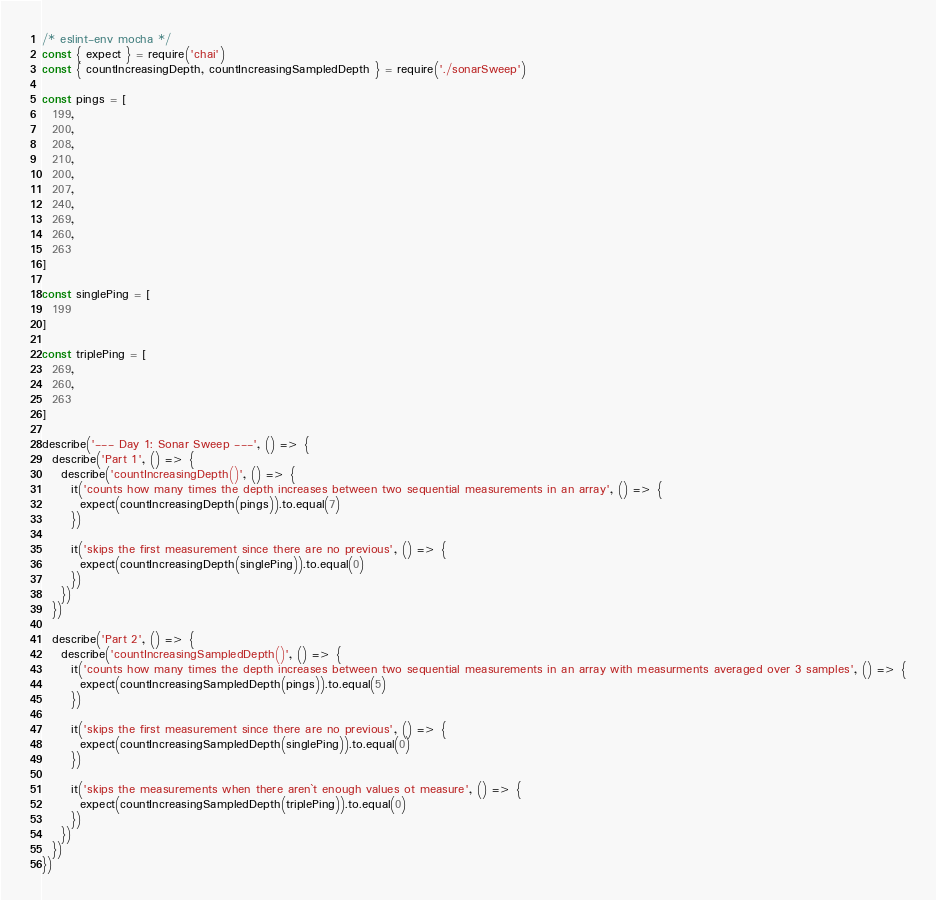<code> <loc_0><loc_0><loc_500><loc_500><_JavaScript_>/* eslint-env mocha */
const { expect } = require('chai')
const { countIncreasingDepth, countIncreasingSampledDepth } = require('./sonarSweep')

const pings = [
  199,
  200,
  208,
  210,
  200,
  207,
  240,
  269,
  260,
  263
]

const singlePing = [
  199
]

const triplePing = [
  269,
  260,
  263
]

describe('--- Day 1: Sonar Sweep ---', () => {
  describe('Part 1', () => {
    describe('countIncreasingDepth()', () => {
      it('counts how many times the depth increases between two sequential measurements in an array', () => {
        expect(countIncreasingDepth(pings)).to.equal(7)
      })

      it('skips the first measurement since there are no previous', () => {
        expect(countIncreasingDepth(singlePing)).to.equal(0)
      })
    })
  })

  describe('Part 2', () => {
    describe('countIncreasingSampledDepth()', () => {
      it('counts how many times the depth increases between two sequential measurements in an array with measurments averaged over 3 samples', () => {
        expect(countIncreasingSampledDepth(pings)).to.equal(5)
      })

      it('skips the first measurement since there are no previous', () => {
        expect(countIncreasingSampledDepth(singlePing)).to.equal(0)
      })

      it('skips the measurements when there aren`t enough values ot measure', () => {
        expect(countIncreasingSampledDepth(triplePing)).to.equal(0)
      })
    })
  })
})
</code> 